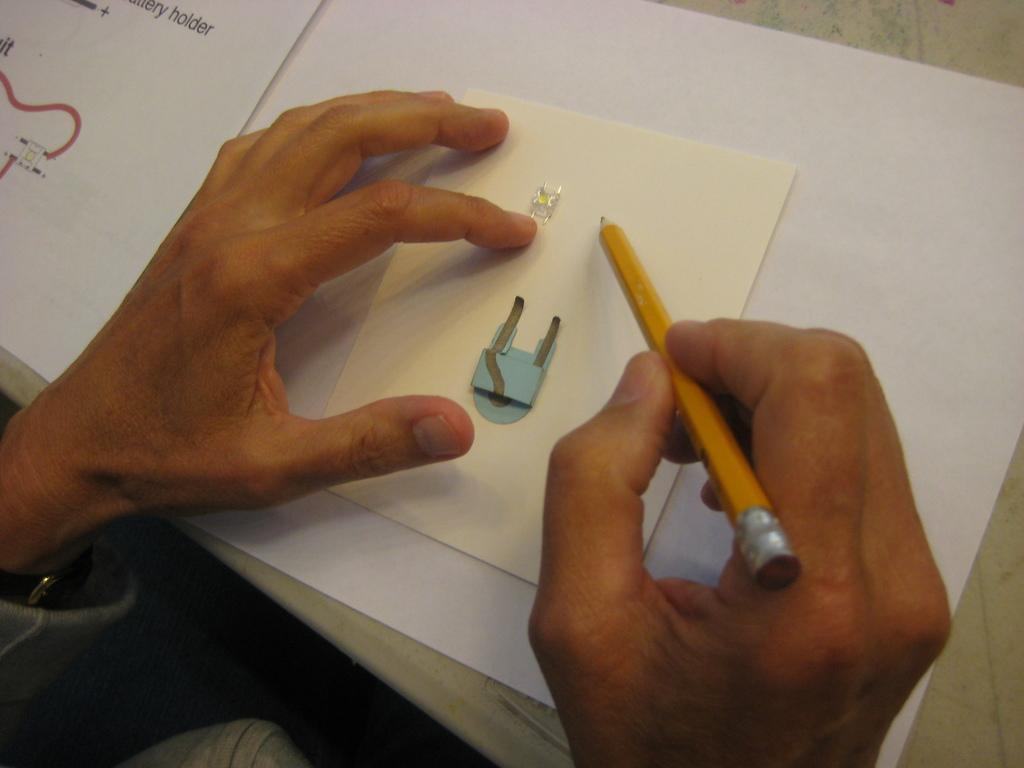What body parts are visible in the image? There are a person's hands in the image. What is the person holding in their hand? The person is holding a pencil in their hand. Can you describe the object in the image? Unfortunately, the provided facts do not give enough information to describe the object in the image. What type of bread can be seen on the calendar in the image? There is no bread or calendar present in the image. 